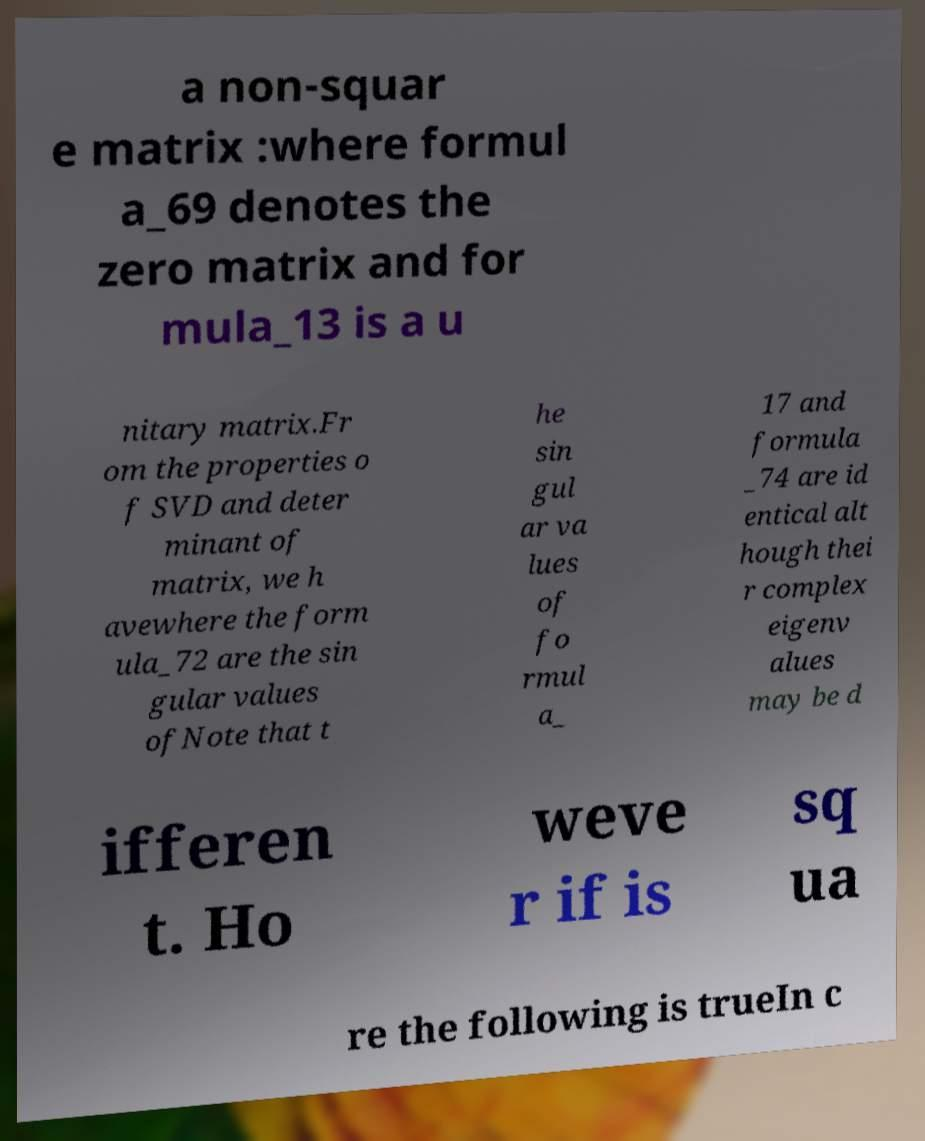What messages or text are displayed in this image? I need them in a readable, typed format. a non-squar e matrix :where formul a_69 denotes the zero matrix and for mula_13 is a u nitary matrix.Fr om the properties o f SVD and deter minant of matrix, we h avewhere the form ula_72 are the sin gular values ofNote that t he sin gul ar va lues of fo rmul a_ 17 and formula _74 are id entical alt hough thei r complex eigenv alues may be d ifferen t. Ho weve r if is sq ua re the following is trueIn c 